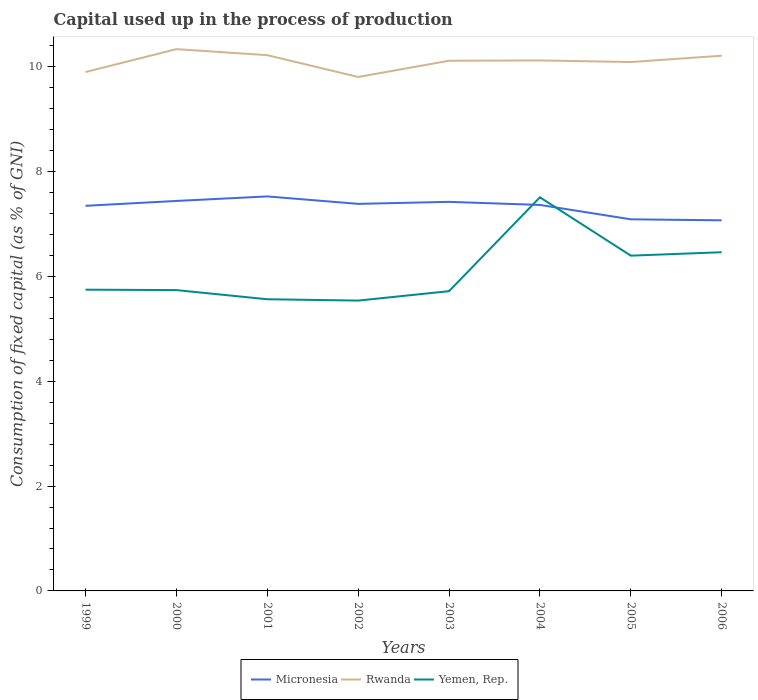How many different coloured lines are there?
Offer a terse response. 3. Is the number of lines equal to the number of legend labels?
Your answer should be compact. Yes. Across all years, what is the maximum capital used up in the process of production in Micronesia?
Your answer should be compact. 7.07. What is the total capital used up in the process of production in Yemen, Rep. in the graph?
Offer a very short reply. -1.76. What is the difference between the highest and the second highest capital used up in the process of production in Yemen, Rep.?
Offer a very short reply. 1.97. What is the difference between the highest and the lowest capital used up in the process of production in Micronesia?
Your answer should be compact. 6. How many lines are there?
Offer a very short reply. 3. Does the graph contain any zero values?
Provide a succinct answer. No. Does the graph contain grids?
Make the answer very short. No. Where does the legend appear in the graph?
Offer a terse response. Bottom center. How are the legend labels stacked?
Your answer should be compact. Horizontal. What is the title of the graph?
Make the answer very short. Capital used up in the process of production. What is the label or title of the Y-axis?
Offer a terse response. Consumption of fixed capital (as % of GNI). What is the Consumption of fixed capital (as % of GNI) in Micronesia in 1999?
Offer a very short reply. 7.35. What is the Consumption of fixed capital (as % of GNI) of Rwanda in 1999?
Make the answer very short. 9.9. What is the Consumption of fixed capital (as % of GNI) in Yemen, Rep. in 1999?
Give a very brief answer. 5.75. What is the Consumption of fixed capital (as % of GNI) in Micronesia in 2000?
Ensure brevity in your answer.  7.44. What is the Consumption of fixed capital (as % of GNI) of Rwanda in 2000?
Your response must be concise. 10.34. What is the Consumption of fixed capital (as % of GNI) of Yemen, Rep. in 2000?
Give a very brief answer. 5.74. What is the Consumption of fixed capital (as % of GNI) in Micronesia in 2001?
Keep it short and to the point. 7.53. What is the Consumption of fixed capital (as % of GNI) in Rwanda in 2001?
Keep it short and to the point. 10.22. What is the Consumption of fixed capital (as % of GNI) of Yemen, Rep. in 2001?
Your response must be concise. 5.57. What is the Consumption of fixed capital (as % of GNI) in Micronesia in 2002?
Ensure brevity in your answer.  7.39. What is the Consumption of fixed capital (as % of GNI) in Rwanda in 2002?
Give a very brief answer. 9.81. What is the Consumption of fixed capital (as % of GNI) in Yemen, Rep. in 2002?
Provide a short and direct response. 5.54. What is the Consumption of fixed capital (as % of GNI) in Micronesia in 2003?
Offer a terse response. 7.42. What is the Consumption of fixed capital (as % of GNI) of Rwanda in 2003?
Provide a short and direct response. 10.12. What is the Consumption of fixed capital (as % of GNI) of Yemen, Rep. in 2003?
Provide a succinct answer. 5.72. What is the Consumption of fixed capital (as % of GNI) of Micronesia in 2004?
Your response must be concise. 7.37. What is the Consumption of fixed capital (as % of GNI) of Rwanda in 2004?
Keep it short and to the point. 10.12. What is the Consumption of fixed capital (as % of GNI) of Yemen, Rep. in 2004?
Keep it short and to the point. 7.51. What is the Consumption of fixed capital (as % of GNI) in Micronesia in 2005?
Your answer should be very brief. 7.09. What is the Consumption of fixed capital (as % of GNI) in Rwanda in 2005?
Your answer should be very brief. 10.09. What is the Consumption of fixed capital (as % of GNI) of Yemen, Rep. in 2005?
Provide a short and direct response. 6.4. What is the Consumption of fixed capital (as % of GNI) of Micronesia in 2006?
Offer a very short reply. 7.07. What is the Consumption of fixed capital (as % of GNI) of Rwanda in 2006?
Provide a succinct answer. 10.21. What is the Consumption of fixed capital (as % of GNI) of Yemen, Rep. in 2006?
Provide a succinct answer. 6.46. Across all years, what is the maximum Consumption of fixed capital (as % of GNI) in Micronesia?
Your response must be concise. 7.53. Across all years, what is the maximum Consumption of fixed capital (as % of GNI) in Rwanda?
Offer a very short reply. 10.34. Across all years, what is the maximum Consumption of fixed capital (as % of GNI) in Yemen, Rep.?
Your response must be concise. 7.51. Across all years, what is the minimum Consumption of fixed capital (as % of GNI) of Micronesia?
Offer a terse response. 7.07. Across all years, what is the minimum Consumption of fixed capital (as % of GNI) in Rwanda?
Make the answer very short. 9.81. Across all years, what is the minimum Consumption of fixed capital (as % of GNI) of Yemen, Rep.?
Offer a very short reply. 5.54. What is the total Consumption of fixed capital (as % of GNI) of Micronesia in the graph?
Provide a short and direct response. 58.66. What is the total Consumption of fixed capital (as % of GNI) in Rwanda in the graph?
Offer a very short reply. 80.81. What is the total Consumption of fixed capital (as % of GNI) in Yemen, Rep. in the graph?
Provide a succinct answer. 48.69. What is the difference between the Consumption of fixed capital (as % of GNI) of Micronesia in 1999 and that in 2000?
Keep it short and to the point. -0.09. What is the difference between the Consumption of fixed capital (as % of GNI) in Rwanda in 1999 and that in 2000?
Keep it short and to the point. -0.44. What is the difference between the Consumption of fixed capital (as % of GNI) in Yemen, Rep. in 1999 and that in 2000?
Keep it short and to the point. 0.01. What is the difference between the Consumption of fixed capital (as % of GNI) in Micronesia in 1999 and that in 2001?
Provide a succinct answer. -0.18. What is the difference between the Consumption of fixed capital (as % of GNI) in Rwanda in 1999 and that in 2001?
Offer a very short reply. -0.32. What is the difference between the Consumption of fixed capital (as % of GNI) of Yemen, Rep. in 1999 and that in 2001?
Provide a succinct answer. 0.18. What is the difference between the Consumption of fixed capital (as % of GNI) in Micronesia in 1999 and that in 2002?
Keep it short and to the point. -0.04. What is the difference between the Consumption of fixed capital (as % of GNI) in Rwanda in 1999 and that in 2002?
Provide a succinct answer. 0.09. What is the difference between the Consumption of fixed capital (as % of GNI) of Yemen, Rep. in 1999 and that in 2002?
Your answer should be compact. 0.21. What is the difference between the Consumption of fixed capital (as % of GNI) of Micronesia in 1999 and that in 2003?
Ensure brevity in your answer.  -0.08. What is the difference between the Consumption of fixed capital (as % of GNI) in Rwanda in 1999 and that in 2003?
Your response must be concise. -0.22. What is the difference between the Consumption of fixed capital (as % of GNI) of Yemen, Rep. in 1999 and that in 2003?
Ensure brevity in your answer.  0.03. What is the difference between the Consumption of fixed capital (as % of GNI) in Micronesia in 1999 and that in 2004?
Give a very brief answer. -0.02. What is the difference between the Consumption of fixed capital (as % of GNI) in Rwanda in 1999 and that in 2004?
Offer a very short reply. -0.22. What is the difference between the Consumption of fixed capital (as % of GNI) in Yemen, Rep. in 1999 and that in 2004?
Your answer should be compact. -1.76. What is the difference between the Consumption of fixed capital (as % of GNI) in Micronesia in 1999 and that in 2005?
Ensure brevity in your answer.  0.26. What is the difference between the Consumption of fixed capital (as % of GNI) of Rwanda in 1999 and that in 2005?
Your answer should be very brief. -0.19. What is the difference between the Consumption of fixed capital (as % of GNI) of Yemen, Rep. in 1999 and that in 2005?
Keep it short and to the point. -0.65. What is the difference between the Consumption of fixed capital (as % of GNI) of Micronesia in 1999 and that in 2006?
Give a very brief answer. 0.28. What is the difference between the Consumption of fixed capital (as % of GNI) in Rwanda in 1999 and that in 2006?
Offer a very short reply. -0.31. What is the difference between the Consumption of fixed capital (as % of GNI) of Yemen, Rep. in 1999 and that in 2006?
Offer a very short reply. -0.71. What is the difference between the Consumption of fixed capital (as % of GNI) in Micronesia in 2000 and that in 2001?
Your response must be concise. -0.09. What is the difference between the Consumption of fixed capital (as % of GNI) in Rwanda in 2000 and that in 2001?
Offer a very short reply. 0.12. What is the difference between the Consumption of fixed capital (as % of GNI) in Yemen, Rep. in 2000 and that in 2001?
Make the answer very short. 0.17. What is the difference between the Consumption of fixed capital (as % of GNI) of Micronesia in 2000 and that in 2002?
Ensure brevity in your answer.  0.06. What is the difference between the Consumption of fixed capital (as % of GNI) of Rwanda in 2000 and that in 2002?
Your response must be concise. 0.53. What is the difference between the Consumption of fixed capital (as % of GNI) of Yemen, Rep. in 2000 and that in 2002?
Provide a short and direct response. 0.2. What is the difference between the Consumption of fixed capital (as % of GNI) of Micronesia in 2000 and that in 2003?
Offer a terse response. 0.02. What is the difference between the Consumption of fixed capital (as % of GNI) in Rwanda in 2000 and that in 2003?
Your response must be concise. 0.22. What is the difference between the Consumption of fixed capital (as % of GNI) in Yemen, Rep. in 2000 and that in 2003?
Offer a very short reply. 0.02. What is the difference between the Consumption of fixed capital (as % of GNI) in Micronesia in 2000 and that in 2004?
Your answer should be very brief. 0.08. What is the difference between the Consumption of fixed capital (as % of GNI) in Rwanda in 2000 and that in 2004?
Make the answer very short. 0.22. What is the difference between the Consumption of fixed capital (as % of GNI) of Yemen, Rep. in 2000 and that in 2004?
Your answer should be compact. -1.77. What is the difference between the Consumption of fixed capital (as % of GNI) of Micronesia in 2000 and that in 2005?
Offer a terse response. 0.35. What is the difference between the Consumption of fixed capital (as % of GNI) of Rwanda in 2000 and that in 2005?
Make the answer very short. 0.25. What is the difference between the Consumption of fixed capital (as % of GNI) in Yemen, Rep. in 2000 and that in 2005?
Make the answer very short. -0.66. What is the difference between the Consumption of fixed capital (as % of GNI) of Micronesia in 2000 and that in 2006?
Ensure brevity in your answer.  0.37. What is the difference between the Consumption of fixed capital (as % of GNI) in Rwanda in 2000 and that in 2006?
Offer a very short reply. 0.13. What is the difference between the Consumption of fixed capital (as % of GNI) in Yemen, Rep. in 2000 and that in 2006?
Give a very brief answer. -0.72. What is the difference between the Consumption of fixed capital (as % of GNI) of Micronesia in 2001 and that in 2002?
Ensure brevity in your answer.  0.14. What is the difference between the Consumption of fixed capital (as % of GNI) of Rwanda in 2001 and that in 2002?
Your answer should be very brief. 0.42. What is the difference between the Consumption of fixed capital (as % of GNI) of Yemen, Rep. in 2001 and that in 2002?
Offer a terse response. 0.03. What is the difference between the Consumption of fixed capital (as % of GNI) of Micronesia in 2001 and that in 2003?
Provide a short and direct response. 0.1. What is the difference between the Consumption of fixed capital (as % of GNI) of Rwanda in 2001 and that in 2003?
Your response must be concise. 0.11. What is the difference between the Consumption of fixed capital (as % of GNI) of Yemen, Rep. in 2001 and that in 2003?
Ensure brevity in your answer.  -0.15. What is the difference between the Consumption of fixed capital (as % of GNI) of Micronesia in 2001 and that in 2004?
Your response must be concise. 0.16. What is the difference between the Consumption of fixed capital (as % of GNI) of Rwanda in 2001 and that in 2004?
Your answer should be very brief. 0.1. What is the difference between the Consumption of fixed capital (as % of GNI) in Yemen, Rep. in 2001 and that in 2004?
Your response must be concise. -1.95. What is the difference between the Consumption of fixed capital (as % of GNI) of Micronesia in 2001 and that in 2005?
Offer a terse response. 0.44. What is the difference between the Consumption of fixed capital (as % of GNI) in Rwanda in 2001 and that in 2005?
Your answer should be very brief. 0.13. What is the difference between the Consumption of fixed capital (as % of GNI) of Yemen, Rep. in 2001 and that in 2005?
Your response must be concise. -0.83. What is the difference between the Consumption of fixed capital (as % of GNI) of Micronesia in 2001 and that in 2006?
Your answer should be very brief. 0.46. What is the difference between the Consumption of fixed capital (as % of GNI) in Rwanda in 2001 and that in 2006?
Ensure brevity in your answer.  0.01. What is the difference between the Consumption of fixed capital (as % of GNI) of Yemen, Rep. in 2001 and that in 2006?
Make the answer very short. -0.9. What is the difference between the Consumption of fixed capital (as % of GNI) of Micronesia in 2002 and that in 2003?
Offer a very short reply. -0.04. What is the difference between the Consumption of fixed capital (as % of GNI) in Rwanda in 2002 and that in 2003?
Offer a very short reply. -0.31. What is the difference between the Consumption of fixed capital (as % of GNI) of Yemen, Rep. in 2002 and that in 2003?
Your answer should be very brief. -0.18. What is the difference between the Consumption of fixed capital (as % of GNI) of Micronesia in 2002 and that in 2004?
Ensure brevity in your answer.  0.02. What is the difference between the Consumption of fixed capital (as % of GNI) of Rwanda in 2002 and that in 2004?
Give a very brief answer. -0.32. What is the difference between the Consumption of fixed capital (as % of GNI) of Yemen, Rep. in 2002 and that in 2004?
Make the answer very short. -1.97. What is the difference between the Consumption of fixed capital (as % of GNI) in Micronesia in 2002 and that in 2005?
Make the answer very short. 0.29. What is the difference between the Consumption of fixed capital (as % of GNI) in Rwanda in 2002 and that in 2005?
Offer a terse response. -0.29. What is the difference between the Consumption of fixed capital (as % of GNI) in Yemen, Rep. in 2002 and that in 2005?
Your answer should be very brief. -0.86. What is the difference between the Consumption of fixed capital (as % of GNI) in Micronesia in 2002 and that in 2006?
Give a very brief answer. 0.31. What is the difference between the Consumption of fixed capital (as % of GNI) of Rwanda in 2002 and that in 2006?
Keep it short and to the point. -0.41. What is the difference between the Consumption of fixed capital (as % of GNI) in Yemen, Rep. in 2002 and that in 2006?
Offer a very short reply. -0.92. What is the difference between the Consumption of fixed capital (as % of GNI) in Micronesia in 2003 and that in 2004?
Give a very brief answer. 0.06. What is the difference between the Consumption of fixed capital (as % of GNI) of Rwanda in 2003 and that in 2004?
Provide a succinct answer. -0.01. What is the difference between the Consumption of fixed capital (as % of GNI) of Yemen, Rep. in 2003 and that in 2004?
Give a very brief answer. -1.79. What is the difference between the Consumption of fixed capital (as % of GNI) of Micronesia in 2003 and that in 2005?
Keep it short and to the point. 0.33. What is the difference between the Consumption of fixed capital (as % of GNI) in Rwanda in 2003 and that in 2005?
Your response must be concise. 0.02. What is the difference between the Consumption of fixed capital (as % of GNI) of Yemen, Rep. in 2003 and that in 2005?
Provide a short and direct response. -0.68. What is the difference between the Consumption of fixed capital (as % of GNI) of Micronesia in 2003 and that in 2006?
Provide a short and direct response. 0.35. What is the difference between the Consumption of fixed capital (as % of GNI) in Rwanda in 2003 and that in 2006?
Keep it short and to the point. -0.1. What is the difference between the Consumption of fixed capital (as % of GNI) in Yemen, Rep. in 2003 and that in 2006?
Make the answer very short. -0.74. What is the difference between the Consumption of fixed capital (as % of GNI) in Micronesia in 2004 and that in 2005?
Make the answer very short. 0.27. What is the difference between the Consumption of fixed capital (as % of GNI) in Rwanda in 2004 and that in 2005?
Your response must be concise. 0.03. What is the difference between the Consumption of fixed capital (as % of GNI) in Yemen, Rep. in 2004 and that in 2005?
Your answer should be very brief. 1.11. What is the difference between the Consumption of fixed capital (as % of GNI) in Micronesia in 2004 and that in 2006?
Your response must be concise. 0.29. What is the difference between the Consumption of fixed capital (as % of GNI) in Rwanda in 2004 and that in 2006?
Make the answer very short. -0.09. What is the difference between the Consumption of fixed capital (as % of GNI) of Yemen, Rep. in 2004 and that in 2006?
Offer a very short reply. 1.05. What is the difference between the Consumption of fixed capital (as % of GNI) of Micronesia in 2005 and that in 2006?
Offer a very short reply. 0.02. What is the difference between the Consumption of fixed capital (as % of GNI) of Rwanda in 2005 and that in 2006?
Offer a very short reply. -0.12. What is the difference between the Consumption of fixed capital (as % of GNI) of Yemen, Rep. in 2005 and that in 2006?
Ensure brevity in your answer.  -0.07. What is the difference between the Consumption of fixed capital (as % of GNI) in Micronesia in 1999 and the Consumption of fixed capital (as % of GNI) in Rwanda in 2000?
Your response must be concise. -2.99. What is the difference between the Consumption of fixed capital (as % of GNI) of Micronesia in 1999 and the Consumption of fixed capital (as % of GNI) of Yemen, Rep. in 2000?
Provide a short and direct response. 1.61. What is the difference between the Consumption of fixed capital (as % of GNI) in Rwanda in 1999 and the Consumption of fixed capital (as % of GNI) in Yemen, Rep. in 2000?
Offer a very short reply. 4.16. What is the difference between the Consumption of fixed capital (as % of GNI) of Micronesia in 1999 and the Consumption of fixed capital (as % of GNI) of Rwanda in 2001?
Provide a succinct answer. -2.87. What is the difference between the Consumption of fixed capital (as % of GNI) of Micronesia in 1999 and the Consumption of fixed capital (as % of GNI) of Yemen, Rep. in 2001?
Offer a very short reply. 1.78. What is the difference between the Consumption of fixed capital (as % of GNI) in Rwanda in 1999 and the Consumption of fixed capital (as % of GNI) in Yemen, Rep. in 2001?
Your response must be concise. 4.34. What is the difference between the Consumption of fixed capital (as % of GNI) of Micronesia in 1999 and the Consumption of fixed capital (as % of GNI) of Rwanda in 2002?
Your response must be concise. -2.46. What is the difference between the Consumption of fixed capital (as % of GNI) of Micronesia in 1999 and the Consumption of fixed capital (as % of GNI) of Yemen, Rep. in 2002?
Your response must be concise. 1.81. What is the difference between the Consumption of fixed capital (as % of GNI) of Rwanda in 1999 and the Consumption of fixed capital (as % of GNI) of Yemen, Rep. in 2002?
Offer a terse response. 4.36. What is the difference between the Consumption of fixed capital (as % of GNI) in Micronesia in 1999 and the Consumption of fixed capital (as % of GNI) in Rwanda in 2003?
Your answer should be compact. -2.77. What is the difference between the Consumption of fixed capital (as % of GNI) in Micronesia in 1999 and the Consumption of fixed capital (as % of GNI) in Yemen, Rep. in 2003?
Offer a very short reply. 1.63. What is the difference between the Consumption of fixed capital (as % of GNI) of Rwanda in 1999 and the Consumption of fixed capital (as % of GNI) of Yemen, Rep. in 2003?
Ensure brevity in your answer.  4.18. What is the difference between the Consumption of fixed capital (as % of GNI) in Micronesia in 1999 and the Consumption of fixed capital (as % of GNI) in Rwanda in 2004?
Provide a succinct answer. -2.77. What is the difference between the Consumption of fixed capital (as % of GNI) in Micronesia in 1999 and the Consumption of fixed capital (as % of GNI) in Yemen, Rep. in 2004?
Provide a succinct answer. -0.16. What is the difference between the Consumption of fixed capital (as % of GNI) in Rwanda in 1999 and the Consumption of fixed capital (as % of GNI) in Yemen, Rep. in 2004?
Ensure brevity in your answer.  2.39. What is the difference between the Consumption of fixed capital (as % of GNI) of Micronesia in 1999 and the Consumption of fixed capital (as % of GNI) of Rwanda in 2005?
Ensure brevity in your answer.  -2.74. What is the difference between the Consumption of fixed capital (as % of GNI) in Micronesia in 1999 and the Consumption of fixed capital (as % of GNI) in Yemen, Rep. in 2005?
Your response must be concise. 0.95. What is the difference between the Consumption of fixed capital (as % of GNI) in Rwanda in 1999 and the Consumption of fixed capital (as % of GNI) in Yemen, Rep. in 2005?
Provide a short and direct response. 3.5. What is the difference between the Consumption of fixed capital (as % of GNI) in Micronesia in 1999 and the Consumption of fixed capital (as % of GNI) in Rwanda in 2006?
Offer a very short reply. -2.86. What is the difference between the Consumption of fixed capital (as % of GNI) in Micronesia in 1999 and the Consumption of fixed capital (as % of GNI) in Yemen, Rep. in 2006?
Offer a terse response. 0.89. What is the difference between the Consumption of fixed capital (as % of GNI) of Rwanda in 1999 and the Consumption of fixed capital (as % of GNI) of Yemen, Rep. in 2006?
Give a very brief answer. 3.44. What is the difference between the Consumption of fixed capital (as % of GNI) of Micronesia in 2000 and the Consumption of fixed capital (as % of GNI) of Rwanda in 2001?
Your answer should be compact. -2.78. What is the difference between the Consumption of fixed capital (as % of GNI) in Micronesia in 2000 and the Consumption of fixed capital (as % of GNI) in Yemen, Rep. in 2001?
Your response must be concise. 1.88. What is the difference between the Consumption of fixed capital (as % of GNI) of Rwanda in 2000 and the Consumption of fixed capital (as % of GNI) of Yemen, Rep. in 2001?
Your response must be concise. 4.77. What is the difference between the Consumption of fixed capital (as % of GNI) in Micronesia in 2000 and the Consumption of fixed capital (as % of GNI) in Rwanda in 2002?
Provide a short and direct response. -2.37. What is the difference between the Consumption of fixed capital (as % of GNI) in Micronesia in 2000 and the Consumption of fixed capital (as % of GNI) in Yemen, Rep. in 2002?
Offer a very short reply. 1.9. What is the difference between the Consumption of fixed capital (as % of GNI) in Rwanda in 2000 and the Consumption of fixed capital (as % of GNI) in Yemen, Rep. in 2002?
Offer a very short reply. 4.8. What is the difference between the Consumption of fixed capital (as % of GNI) of Micronesia in 2000 and the Consumption of fixed capital (as % of GNI) of Rwanda in 2003?
Offer a very short reply. -2.67. What is the difference between the Consumption of fixed capital (as % of GNI) of Micronesia in 2000 and the Consumption of fixed capital (as % of GNI) of Yemen, Rep. in 2003?
Provide a succinct answer. 1.72. What is the difference between the Consumption of fixed capital (as % of GNI) in Rwanda in 2000 and the Consumption of fixed capital (as % of GNI) in Yemen, Rep. in 2003?
Ensure brevity in your answer.  4.62. What is the difference between the Consumption of fixed capital (as % of GNI) of Micronesia in 2000 and the Consumption of fixed capital (as % of GNI) of Rwanda in 2004?
Provide a short and direct response. -2.68. What is the difference between the Consumption of fixed capital (as % of GNI) in Micronesia in 2000 and the Consumption of fixed capital (as % of GNI) in Yemen, Rep. in 2004?
Provide a short and direct response. -0.07. What is the difference between the Consumption of fixed capital (as % of GNI) of Rwanda in 2000 and the Consumption of fixed capital (as % of GNI) of Yemen, Rep. in 2004?
Your answer should be compact. 2.83. What is the difference between the Consumption of fixed capital (as % of GNI) in Micronesia in 2000 and the Consumption of fixed capital (as % of GNI) in Rwanda in 2005?
Offer a very short reply. -2.65. What is the difference between the Consumption of fixed capital (as % of GNI) of Micronesia in 2000 and the Consumption of fixed capital (as % of GNI) of Yemen, Rep. in 2005?
Give a very brief answer. 1.04. What is the difference between the Consumption of fixed capital (as % of GNI) of Rwanda in 2000 and the Consumption of fixed capital (as % of GNI) of Yemen, Rep. in 2005?
Give a very brief answer. 3.94. What is the difference between the Consumption of fixed capital (as % of GNI) of Micronesia in 2000 and the Consumption of fixed capital (as % of GNI) of Rwanda in 2006?
Offer a very short reply. -2.77. What is the difference between the Consumption of fixed capital (as % of GNI) in Micronesia in 2000 and the Consumption of fixed capital (as % of GNI) in Yemen, Rep. in 2006?
Keep it short and to the point. 0.98. What is the difference between the Consumption of fixed capital (as % of GNI) in Rwanda in 2000 and the Consumption of fixed capital (as % of GNI) in Yemen, Rep. in 2006?
Keep it short and to the point. 3.88. What is the difference between the Consumption of fixed capital (as % of GNI) of Micronesia in 2001 and the Consumption of fixed capital (as % of GNI) of Rwanda in 2002?
Make the answer very short. -2.28. What is the difference between the Consumption of fixed capital (as % of GNI) in Micronesia in 2001 and the Consumption of fixed capital (as % of GNI) in Yemen, Rep. in 2002?
Your answer should be very brief. 1.99. What is the difference between the Consumption of fixed capital (as % of GNI) in Rwanda in 2001 and the Consumption of fixed capital (as % of GNI) in Yemen, Rep. in 2002?
Provide a short and direct response. 4.68. What is the difference between the Consumption of fixed capital (as % of GNI) of Micronesia in 2001 and the Consumption of fixed capital (as % of GNI) of Rwanda in 2003?
Make the answer very short. -2.59. What is the difference between the Consumption of fixed capital (as % of GNI) of Micronesia in 2001 and the Consumption of fixed capital (as % of GNI) of Yemen, Rep. in 2003?
Ensure brevity in your answer.  1.81. What is the difference between the Consumption of fixed capital (as % of GNI) of Rwanda in 2001 and the Consumption of fixed capital (as % of GNI) of Yemen, Rep. in 2003?
Provide a short and direct response. 4.5. What is the difference between the Consumption of fixed capital (as % of GNI) of Micronesia in 2001 and the Consumption of fixed capital (as % of GNI) of Rwanda in 2004?
Ensure brevity in your answer.  -2.59. What is the difference between the Consumption of fixed capital (as % of GNI) in Micronesia in 2001 and the Consumption of fixed capital (as % of GNI) in Yemen, Rep. in 2004?
Your response must be concise. 0.02. What is the difference between the Consumption of fixed capital (as % of GNI) of Rwanda in 2001 and the Consumption of fixed capital (as % of GNI) of Yemen, Rep. in 2004?
Provide a succinct answer. 2.71. What is the difference between the Consumption of fixed capital (as % of GNI) in Micronesia in 2001 and the Consumption of fixed capital (as % of GNI) in Rwanda in 2005?
Your response must be concise. -2.56. What is the difference between the Consumption of fixed capital (as % of GNI) in Micronesia in 2001 and the Consumption of fixed capital (as % of GNI) in Yemen, Rep. in 2005?
Offer a very short reply. 1.13. What is the difference between the Consumption of fixed capital (as % of GNI) of Rwanda in 2001 and the Consumption of fixed capital (as % of GNI) of Yemen, Rep. in 2005?
Ensure brevity in your answer.  3.83. What is the difference between the Consumption of fixed capital (as % of GNI) of Micronesia in 2001 and the Consumption of fixed capital (as % of GNI) of Rwanda in 2006?
Your response must be concise. -2.68. What is the difference between the Consumption of fixed capital (as % of GNI) in Micronesia in 2001 and the Consumption of fixed capital (as % of GNI) in Yemen, Rep. in 2006?
Offer a terse response. 1.06. What is the difference between the Consumption of fixed capital (as % of GNI) in Rwanda in 2001 and the Consumption of fixed capital (as % of GNI) in Yemen, Rep. in 2006?
Provide a short and direct response. 3.76. What is the difference between the Consumption of fixed capital (as % of GNI) in Micronesia in 2002 and the Consumption of fixed capital (as % of GNI) in Rwanda in 2003?
Keep it short and to the point. -2.73. What is the difference between the Consumption of fixed capital (as % of GNI) of Micronesia in 2002 and the Consumption of fixed capital (as % of GNI) of Yemen, Rep. in 2003?
Keep it short and to the point. 1.67. What is the difference between the Consumption of fixed capital (as % of GNI) of Rwanda in 2002 and the Consumption of fixed capital (as % of GNI) of Yemen, Rep. in 2003?
Keep it short and to the point. 4.09. What is the difference between the Consumption of fixed capital (as % of GNI) of Micronesia in 2002 and the Consumption of fixed capital (as % of GNI) of Rwanda in 2004?
Provide a short and direct response. -2.74. What is the difference between the Consumption of fixed capital (as % of GNI) of Micronesia in 2002 and the Consumption of fixed capital (as % of GNI) of Yemen, Rep. in 2004?
Keep it short and to the point. -0.13. What is the difference between the Consumption of fixed capital (as % of GNI) of Rwanda in 2002 and the Consumption of fixed capital (as % of GNI) of Yemen, Rep. in 2004?
Your answer should be compact. 2.3. What is the difference between the Consumption of fixed capital (as % of GNI) of Micronesia in 2002 and the Consumption of fixed capital (as % of GNI) of Rwanda in 2005?
Your answer should be compact. -2.71. What is the difference between the Consumption of fixed capital (as % of GNI) in Micronesia in 2002 and the Consumption of fixed capital (as % of GNI) in Yemen, Rep. in 2005?
Your response must be concise. 0.99. What is the difference between the Consumption of fixed capital (as % of GNI) in Rwanda in 2002 and the Consumption of fixed capital (as % of GNI) in Yemen, Rep. in 2005?
Make the answer very short. 3.41. What is the difference between the Consumption of fixed capital (as % of GNI) of Micronesia in 2002 and the Consumption of fixed capital (as % of GNI) of Rwanda in 2006?
Ensure brevity in your answer.  -2.83. What is the difference between the Consumption of fixed capital (as % of GNI) of Micronesia in 2002 and the Consumption of fixed capital (as % of GNI) of Yemen, Rep. in 2006?
Give a very brief answer. 0.92. What is the difference between the Consumption of fixed capital (as % of GNI) in Rwanda in 2002 and the Consumption of fixed capital (as % of GNI) in Yemen, Rep. in 2006?
Your answer should be very brief. 3.34. What is the difference between the Consumption of fixed capital (as % of GNI) in Micronesia in 2003 and the Consumption of fixed capital (as % of GNI) in Rwanda in 2004?
Provide a succinct answer. -2.7. What is the difference between the Consumption of fixed capital (as % of GNI) of Micronesia in 2003 and the Consumption of fixed capital (as % of GNI) of Yemen, Rep. in 2004?
Provide a succinct answer. -0.09. What is the difference between the Consumption of fixed capital (as % of GNI) in Rwanda in 2003 and the Consumption of fixed capital (as % of GNI) in Yemen, Rep. in 2004?
Your response must be concise. 2.61. What is the difference between the Consumption of fixed capital (as % of GNI) in Micronesia in 2003 and the Consumption of fixed capital (as % of GNI) in Rwanda in 2005?
Offer a terse response. -2.67. What is the difference between the Consumption of fixed capital (as % of GNI) of Micronesia in 2003 and the Consumption of fixed capital (as % of GNI) of Yemen, Rep. in 2005?
Your response must be concise. 1.03. What is the difference between the Consumption of fixed capital (as % of GNI) in Rwanda in 2003 and the Consumption of fixed capital (as % of GNI) in Yemen, Rep. in 2005?
Ensure brevity in your answer.  3.72. What is the difference between the Consumption of fixed capital (as % of GNI) in Micronesia in 2003 and the Consumption of fixed capital (as % of GNI) in Rwanda in 2006?
Make the answer very short. -2.79. What is the difference between the Consumption of fixed capital (as % of GNI) in Micronesia in 2003 and the Consumption of fixed capital (as % of GNI) in Yemen, Rep. in 2006?
Provide a succinct answer. 0.96. What is the difference between the Consumption of fixed capital (as % of GNI) of Rwanda in 2003 and the Consumption of fixed capital (as % of GNI) of Yemen, Rep. in 2006?
Give a very brief answer. 3.65. What is the difference between the Consumption of fixed capital (as % of GNI) in Micronesia in 2004 and the Consumption of fixed capital (as % of GNI) in Rwanda in 2005?
Make the answer very short. -2.73. What is the difference between the Consumption of fixed capital (as % of GNI) in Micronesia in 2004 and the Consumption of fixed capital (as % of GNI) in Yemen, Rep. in 2005?
Ensure brevity in your answer.  0.97. What is the difference between the Consumption of fixed capital (as % of GNI) of Rwanda in 2004 and the Consumption of fixed capital (as % of GNI) of Yemen, Rep. in 2005?
Your response must be concise. 3.73. What is the difference between the Consumption of fixed capital (as % of GNI) in Micronesia in 2004 and the Consumption of fixed capital (as % of GNI) in Rwanda in 2006?
Keep it short and to the point. -2.85. What is the difference between the Consumption of fixed capital (as % of GNI) in Micronesia in 2004 and the Consumption of fixed capital (as % of GNI) in Yemen, Rep. in 2006?
Your answer should be compact. 0.9. What is the difference between the Consumption of fixed capital (as % of GNI) of Rwanda in 2004 and the Consumption of fixed capital (as % of GNI) of Yemen, Rep. in 2006?
Your response must be concise. 3.66. What is the difference between the Consumption of fixed capital (as % of GNI) of Micronesia in 2005 and the Consumption of fixed capital (as % of GNI) of Rwanda in 2006?
Ensure brevity in your answer.  -3.12. What is the difference between the Consumption of fixed capital (as % of GNI) in Micronesia in 2005 and the Consumption of fixed capital (as % of GNI) in Yemen, Rep. in 2006?
Ensure brevity in your answer.  0.63. What is the difference between the Consumption of fixed capital (as % of GNI) in Rwanda in 2005 and the Consumption of fixed capital (as % of GNI) in Yemen, Rep. in 2006?
Keep it short and to the point. 3.63. What is the average Consumption of fixed capital (as % of GNI) of Micronesia per year?
Your answer should be very brief. 7.33. What is the average Consumption of fixed capital (as % of GNI) in Rwanda per year?
Keep it short and to the point. 10.1. What is the average Consumption of fixed capital (as % of GNI) of Yemen, Rep. per year?
Provide a succinct answer. 6.09. In the year 1999, what is the difference between the Consumption of fixed capital (as % of GNI) in Micronesia and Consumption of fixed capital (as % of GNI) in Rwanda?
Make the answer very short. -2.55. In the year 1999, what is the difference between the Consumption of fixed capital (as % of GNI) of Micronesia and Consumption of fixed capital (as % of GNI) of Yemen, Rep.?
Provide a short and direct response. 1.6. In the year 1999, what is the difference between the Consumption of fixed capital (as % of GNI) of Rwanda and Consumption of fixed capital (as % of GNI) of Yemen, Rep.?
Offer a terse response. 4.15. In the year 2000, what is the difference between the Consumption of fixed capital (as % of GNI) in Micronesia and Consumption of fixed capital (as % of GNI) in Rwanda?
Ensure brevity in your answer.  -2.9. In the year 2000, what is the difference between the Consumption of fixed capital (as % of GNI) of Micronesia and Consumption of fixed capital (as % of GNI) of Yemen, Rep.?
Offer a terse response. 1.7. In the year 2000, what is the difference between the Consumption of fixed capital (as % of GNI) of Rwanda and Consumption of fixed capital (as % of GNI) of Yemen, Rep.?
Your answer should be very brief. 4.6. In the year 2001, what is the difference between the Consumption of fixed capital (as % of GNI) in Micronesia and Consumption of fixed capital (as % of GNI) in Rwanda?
Your response must be concise. -2.7. In the year 2001, what is the difference between the Consumption of fixed capital (as % of GNI) in Micronesia and Consumption of fixed capital (as % of GNI) in Yemen, Rep.?
Your response must be concise. 1.96. In the year 2001, what is the difference between the Consumption of fixed capital (as % of GNI) of Rwanda and Consumption of fixed capital (as % of GNI) of Yemen, Rep.?
Offer a very short reply. 4.66. In the year 2002, what is the difference between the Consumption of fixed capital (as % of GNI) in Micronesia and Consumption of fixed capital (as % of GNI) in Rwanda?
Give a very brief answer. -2.42. In the year 2002, what is the difference between the Consumption of fixed capital (as % of GNI) in Micronesia and Consumption of fixed capital (as % of GNI) in Yemen, Rep.?
Ensure brevity in your answer.  1.85. In the year 2002, what is the difference between the Consumption of fixed capital (as % of GNI) in Rwanda and Consumption of fixed capital (as % of GNI) in Yemen, Rep.?
Ensure brevity in your answer.  4.27. In the year 2003, what is the difference between the Consumption of fixed capital (as % of GNI) in Micronesia and Consumption of fixed capital (as % of GNI) in Rwanda?
Your response must be concise. -2.69. In the year 2003, what is the difference between the Consumption of fixed capital (as % of GNI) of Micronesia and Consumption of fixed capital (as % of GNI) of Yemen, Rep.?
Provide a succinct answer. 1.7. In the year 2003, what is the difference between the Consumption of fixed capital (as % of GNI) of Rwanda and Consumption of fixed capital (as % of GNI) of Yemen, Rep.?
Offer a very short reply. 4.4. In the year 2004, what is the difference between the Consumption of fixed capital (as % of GNI) of Micronesia and Consumption of fixed capital (as % of GNI) of Rwanda?
Provide a succinct answer. -2.76. In the year 2004, what is the difference between the Consumption of fixed capital (as % of GNI) in Micronesia and Consumption of fixed capital (as % of GNI) in Yemen, Rep.?
Offer a very short reply. -0.15. In the year 2004, what is the difference between the Consumption of fixed capital (as % of GNI) in Rwanda and Consumption of fixed capital (as % of GNI) in Yemen, Rep.?
Offer a terse response. 2.61. In the year 2005, what is the difference between the Consumption of fixed capital (as % of GNI) of Micronesia and Consumption of fixed capital (as % of GNI) of Rwanda?
Provide a short and direct response. -3. In the year 2005, what is the difference between the Consumption of fixed capital (as % of GNI) in Micronesia and Consumption of fixed capital (as % of GNI) in Yemen, Rep.?
Your answer should be very brief. 0.69. In the year 2005, what is the difference between the Consumption of fixed capital (as % of GNI) of Rwanda and Consumption of fixed capital (as % of GNI) of Yemen, Rep.?
Your answer should be compact. 3.69. In the year 2006, what is the difference between the Consumption of fixed capital (as % of GNI) in Micronesia and Consumption of fixed capital (as % of GNI) in Rwanda?
Provide a succinct answer. -3.14. In the year 2006, what is the difference between the Consumption of fixed capital (as % of GNI) of Micronesia and Consumption of fixed capital (as % of GNI) of Yemen, Rep.?
Your answer should be very brief. 0.61. In the year 2006, what is the difference between the Consumption of fixed capital (as % of GNI) in Rwanda and Consumption of fixed capital (as % of GNI) in Yemen, Rep.?
Provide a short and direct response. 3.75. What is the ratio of the Consumption of fixed capital (as % of GNI) in Micronesia in 1999 to that in 2000?
Your response must be concise. 0.99. What is the ratio of the Consumption of fixed capital (as % of GNI) of Rwanda in 1999 to that in 2000?
Your answer should be very brief. 0.96. What is the ratio of the Consumption of fixed capital (as % of GNI) of Yemen, Rep. in 1999 to that in 2000?
Offer a very short reply. 1. What is the ratio of the Consumption of fixed capital (as % of GNI) of Micronesia in 1999 to that in 2001?
Make the answer very short. 0.98. What is the ratio of the Consumption of fixed capital (as % of GNI) in Rwanda in 1999 to that in 2001?
Offer a very short reply. 0.97. What is the ratio of the Consumption of fixed capital (as % of GNI) of Yemen, Rep. in 1999 to that in 2001?
Ensure brevity in your answer.  1.03. What is the ratio of the Consumption of fixed capital (as % of GNI) of Micronesia in 1999 to that in 2002?
Ensure brevity in your answer.  0.99. What is the ratio of the Consumption of fixed capital (as % of GNI) in Rwanda in 1999 to that in 2002?
Your answer should be compact. 1.01. What is the ratio of the Consumption of fixed capital (as % of GNI) of Yemen, Rep. in 1999 to that in 2002?
Give a very brief answer. 1.04. What is the ratio of the Consumption of fixed capital (as % of GNI) in Rwanda in 1999 to that in 2003?
Ensure brevity in your answer.  0.98. What is the ratio of the Consumption of fixed capital (as % of GNI) of Micronesia in 1999 to that in 2004?
Provide a short and direct response. 1. What is the ratio of the Consumption of fixed capital (as % of GNI) of Rwanda in 1999 to that in 2004?
Provide a short and direct response. 0.98. What is the ratio of the Consumption of fixed capital (as % of GNI) in Yemen, Rep. in 1999 to that in 2004?
Your answer should be very brief. 0.77. What is the ratio of the Consumption of fixed capital (as % of GNI) in Micronesia in 1999 to that in 2005?
Ensure brevity in your answer.  1.04. What is the ratio of the Consumption of fixed capital (as % of GNI) in Rwanda in 1999 to that in 2005?
Make the answer very short. 0.98. What is the ratio of the Consumption of fixed capital (as % of GNI) in Yemen, Rep. in 1999 to that in 2005?
Your answer should be very brief. 0.9. What is the ratio of the Consumption of fixed capital (as % of GNI) in Micronesia in 1999 to that in 2006?
Your answer should be compact. 1.04. What is the ratio of the Consumption of fixed capital (as % of GNI) of Rwanda in 1999 to that in 2006?
Your answer should be very brief. 0.97. What is the ratio of the Consumption of fixed capital (as % of GNI) of Yemen, Rep. in 1999 to that in 2006?
Your answer should be compact. 0.89. What is the ratio of the Consumption of fixed capital (as % of GNI) in Rwanda in 2000 to that in 2001?
Give a very brief answer. 1.01. What is the ratio of the Consumption of fixed capital (as % of GNI) in Yemen, Rep. in 2000 to that in 2001?
Offer a terse response. 1.03. What is the ratio of the Consumption of fixed capital (as % of GNI) of Micronesia in 2000 to that in 2002?
Keep it short and to the point. 1.01. What is the ratio of the Consumption of fixed capital (as % of GNI) of Rwanda in 2000 to that in 2002?
Your response must be concise. 1.05. What is the ratio of the Consumption of fixed capital (as % of GNI) of Yemen, Rep. in 2000 to that in 2002?
Offer a terse response. 1.04. What is the ratio of the Consumption of fixed capital (as % of GNI) in Rwanda in 2000 to that in 2003?
Offer a terse response. 1.02. What is the ratio of the Consumption of fixed capital (as % of GNI) of Yemen, Rep. in 2000 to that in 2003?
Your response must be concise. 1. What is the ratio of the Consumption of fixed capital (as % of GNI) of Micronesia in 2000 to that in 2004?
Make the answer very short. 1.01. What is the ratio of the Consumption of fixed capital (as % of GNI) in Rwanda in 2000 to that in 2004?
Provide a short and direct response. 1.02. What is the ratio of the Consumption of fixed capital (as % of GNI) of Yemen, Rep. in 2000 to that in 2004?
Offer a terse response. 0.76. What is the ratio of the Consumption of fixed capital (as % of GNI) in Micronesia in 2000 to that in 2005?
Make the answer very short. 1.05. What is the ratio of the Consumption of fixed capital (as % of GNI) of Rwanda in 2000 to that in 2005?
Make the answer very short. 1.02. What is the ratio of the Consumption of fixed capital (as % of GNI) in Yemen, Rep. in 2000 to that in 2005?
Offer a terse response. 0.9. What is the ratio of the Consumption of fixed capital (as % of GNI) of Micronesia in 2000 to that in 2006?
Offer a terse response. 1.05. What is the ratio of the Consumption of fixed capital (as % of GNI) of Rwanda in 2000 to that in 2006?
Provide a short and direct response. 1.01. What is the ratio of the Consumption of fixed capital (as % of GNI) of Yemen, Rep. in 2000 to that in 2006?
Give a very brief answer. 0.89. What is the ratio of the Consumption of fixed capital (as % of GNI) in Micronesia in 2001 to that in 2002?
Your answer should be very brief. 1.02. What is the ratio of the Consumption of fixed capital (as % of GNI) in Rwanda in 2001 to that in 2002?
Keep it short and to the point. 1.04. What is the ratio of the Consumption of fixed capital (as % of GNI) of Yemen, Rep. in 2001 to that in 2002?
Your answer should be very brief. 1. What is the ratio of the Consumption of fixed capital (as % of GNI) of Rwanda in 2001 to that in 2003?
Offer a terse response. 1.01. What is the ratio of the Consumption of fixed capital (as % of GNI) in Yemen, Rep. in 2001 to that in 2003?
Give a very brief answer. 0.97. What is the ratio of the Consumption of fixed capital (as % of GNI) of Micronesia in 2001 to that in 2004?
Keep it short and to the point. 1.02. What is the ratio of the Consumption of fixed capital (as % of GNI) of Rwanda in 2001 to that in 2004?
Offer a very short reply. 1.01. What is the ratio of the Consumption of fixed capital (as % of GNI) of Yemen, Rep. in 2001 to that in 2004?
Offer a terse response. 0.74. What is the ratio of the Consumption of fixed capital (as % of GNI) of Micronesia in 2001 to that in 2005?
Make the answer very short. 1.06. What is the ratio of the Consumption of fixed capital (as % of GNI) of Rwanda in 2001 to that in 2005?
Provide a succinct answer. 1.01. What is the ratio of the Consumption of fixed capital (as % of GNI) in Yemen, Rep. in 2001 to that in 2005?
Ensure brevity in your answer.  0.87. What is the ratio of the Consumption of fixed capital (as % of GNI) in Micronesia in 2001 to that in 2006?
Your answer should be compact. 1.06. What is the ratio of the Consumption of fixed capital (as % of GNI) of Yemen, Rep. in 2001 to that in 2006?
Offer a terse response. 0.86. What is the ratio of the Consumption of fixed capital (as % of GNI) in Micronesia in 2002 to that in 2003?
Your answer should be very brief. 0.99. What is the ratio of the Consumption of fixed capital (as % of GNI) in Rwanda in 2002 to that in 2003?
Provide a short and direct response. 0.97. What is the ratio of the Consumption of fixed capital (as % of GNI) of Yemen, Rep. in 2002 to that in 2003?
Your answer should be very brief. 0.97. What is the ratio of the Consumption of fixed capital (as % of GNI) in Rwanda in 2002 to that in 2004?
Provide a succinct answer. 0.97. What is the ratio of the Consumption of fixed capital (as % of GNI) of Yemen, Rep. in 2002 to that in 2004?
Offer a terse response. 0.74. What is the ratio of the Consumption of fixed capital (as % of GNI) in Micronesia in 2002 to that in 2005?
Ensure brevity in your answer.  1.04. What is the ratio of the Consumption of fixed capital (as % of GNI) in Rwanda in 2002 to that in 2005?
Give a very brief answer. 0.97. What is the ratio of the Consumption of fixed capital (as % of GNI) in Yemen, Rep. in 2002 to that in 2005?
Keep it short and to the point. 0.87. What is the ratio of the Consumption of fixed capital (as % of GNI) of Micronesia in 2002 to that in 2006?
Give a very brief answer. 1.04. What is the ratio of the Consumption of fixed capital (as % of GNI) in Rwanda in 2002 to that in 2006?
Provide a succinct answer. 0.96. What is the ratio of the Consumption of fixed capital (as % of GNI) in Yemen, Rep. in 2002 to that in 2006?
Provide a succinct answer. 0.86. What is the ratio of the Consumption of fixed capital (as % of GNI) in Micronesia in 2003 to that in 2004?
Make the answer very short. 1.01. What is the ratio of the Consumption of fixed capital (as % of GNI) of Rwanda in 2003 to that in 2004?
Provide a succinct answer. 1. What is the ratio of the Consumption of fixed capital (as % of GNI) of Yemen, Rep. in 2003 to that in 2004?
Keep it short and to the point. 0.76. What is the ratio of the Consumption of fixed capital (as % of GNI) of Micronesia in 2003 to that in 2005?
Make the answer very short. 1.05. What is the ratio of the Consumption of fixed capital (as % of GNI) of Rwanda in 2003 to that in 2005?
Make the answer very short. 1. What is the ratio of the Consumption of fixed capital (as % of GNI) of Yemen, Rep. in 2003 to that in 2005?
Your answer should be very brief. 0.89. What is the ratio of the Consumption of fixed capital (as % of GNI) in Micronesia in 2003 to that in 2006?
Keep it short and to the point. 1.05. What is the ratio of the Consumption of fixed capital (as % of GNI) in Rwanda in 2003 to that in 2006?
Offer a very short reply. 0.99. What is the ratio of the Consumption of fixed capital (as % of GNI) in Yemen, Rep. in 2003 to that in 2006?
Offer a terse response. 0.89. What is the ratio of the Consumption of fixed capital (as % of GNI) of Micronesia in 2004 to that in 2005?
Offer a very short reply. 1.04. What is the ratio of the Consumption of fixed capital (as % of GNI) in Rwanda in 2004 to that in 2005?
Your answer should be very brief. 1. What is the ratio of the Consumption of fixed capital (as % of GNI) in Yemen, Rep. in 2004 to that in 2005?
Keep it short and to the point. 1.17. What is the ratio of the Consumption of fixed capital (as % of GNI) in Micronesia in 2004 to that in 2006?
Ensure brevity in your answer.  1.04. What is the ratio of the Consumption of fixed capital (as % of GNI) in Yemen, Rep. in 2004 to that in 2006?
Your response must be concise. 1.16. What is the ratio of the Consumption of fixed capital (as % of GNI) of Micronesia in 2005 to that in 2006?
Your answer should be very brief. 1. What is the ratio of the Consumption of fixed capital (as % of GNI) in Rwanda in 2005 to that in 2006?
Keep it short and to the point. 0.99. What is the difference between the highest and the second highest Consumption of fixed capital (as % of GNI) in Micronesia?
Your answer should be compact. 0.09. What is the difference between the highest and the second highest Consumption of fixed capital (as % of GNI) of Rwanda?
Offer a very short reply. 0.12. What is the difference between the highest and the second highest Consumption of fixed capital (as % of GNI) of Yemen, Rep.?
Your answer should be compact. 1.05. What is the difference between the highest and the lowest Consumption of fixed capital (as % of GNI) in Micronesia?
Offer a terse response. 0.46. What is the difference between the highest and the lowest Consumption of fixed capital (as % of GNI) in Rwanda?
Offer a terse response. 0.53. What is the difference between the highest and the lowest Consumption of fixed capital (as % of GNI) of Yemen, Rep.?
Ensure brevity in your answer.  1.97. 